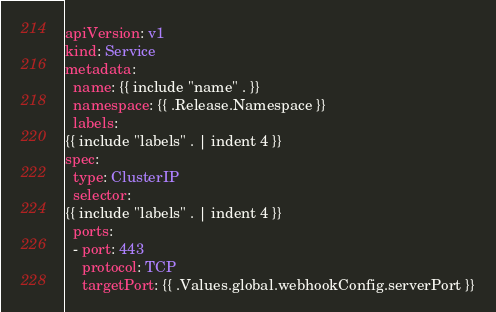Convert code to text. <code><loc_0><loc_0><loc_500><loc_500><_YAML_>apiVersion: v1
kind: Service
metadata:
  name: {{ include "name" . }}
  namespace: {{ .Release.Namespace }}
  labels:
{{ include "labels" . | indent 4 }}
spec:
  type: ClusterIP
  selector:
{{ include "labels" . | indent 4 }}
  ports:
  - port: 443
    protocol: TCP
    targetPort: {{ .Values.global.webhookConfig.serverPort }}</code> 